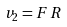<formula> <loc_0><loc_0><loc_500><loc_500>v _ { 2 } = F \, R</formula> 